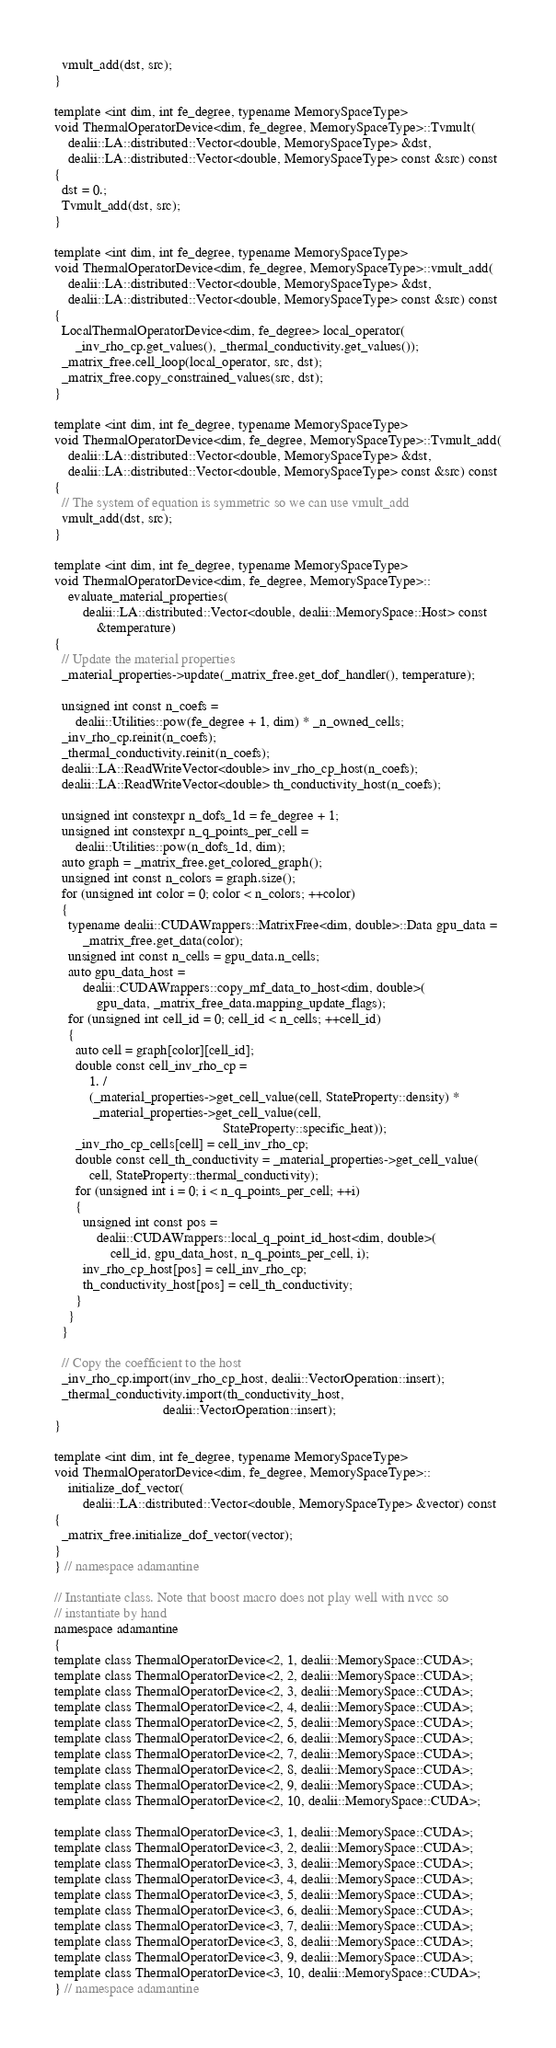Convert code to text. <code><loc_0><loc_0><loc_500><loc_500><_Cuda_>  vmult_add(dst, src);
}

template <int dim, int fe_degree, typename MemorySpaceType>
void ThermalOperatorDevice<dim, fe_degree, MemorySpaceType>::Tvmult(
    dealii::LA::distributed::Vector<double, MemorySpaceType> &dst,
    dealii::LA::distributed::Vector<double, MemorySpaceType> const &src) const
{
  dst = 0.;
  Tvmult_add(dst, src);
}

template <int dim, int fe_degree, typename MemorySpaceType>
void ThermalOperatorDevice<dim, fe_degree, MemorySpaceType>::vmult_add(
    dealii::LA::distributed::Vector<double, MemorySpaceType> &dst,
    dealii::LA::distributed::Vector<double, MemorySpaceType> const &src) const
{
  LocalThermalOperatorDevice<dim, fe_degree> local_operator(
      _inv_rho_cp.get_values(), _thermal_conductivity.get_values());
  _matrix_free.cell_loop(local_operator, src, dst);
  _matrix_free.copy_constrained_values(src, dst);
}

template <int dim, int fe_degree, typename MemorySpaceType>
void ThermalOperatorDevice<dim, fe_degree, MemorySpaceType>::Tvmult_add(
    dealii::LA::distributed::Vector<double, MemorySpaceType> &dst,
    dealii::LA::distributed::Vector<double, MemorySpaceType> const &src) const
{
  // The system of equation is symmetric so we can use vmult_add
  vmult_add(dst, src);
}

template <int dim, int fe_degree, typename MemorySpaceType>
void ThermalOperatorDevice<dim, fe_degree, MemorySpaceType>::
    evaluate_material_properties(
        dealii::LA::distributed::Vector<double, dealii::MemorySpace::Host> const
            &temperature)
{
  // Update the material properties
  _material_properties->update(_matrix_free.get_dof_handler(), temperature);

  unsigned int const n_coefs =
      dealii::Utilities::pow(fe_degree + 1, dim) * _n_owned_cells;
  _inv_rho_cp.reinit(n_coefs);
  _thermal_conductivity.reinit(n_coefs);
  dealii::LA::ReadWriteVector<double> inv_rho_cp_host(n_coefs);
  dealii::LA::ReadWriteVector<double> th_conductivity_host(n_coefs);

  unsigned int constexpr n_dofs_1d = fe_degree + 1;
  unsigned int constexpr n_q_points_per_cell =
      dealii::Utilities::pow(n_dofs_1d, dim);
  auto graph = _matrix_free.get_colored_graph();
  unsigned int const n_colors = graph.size();
  for (unsigned int color = 0; color < n_colors; ++color)
  {
    typename dealii::CUDAWrappers::MatrixFree<dim, double>::Data gpu_data =
        _matrix_free.get_data(color);
    unsigned int const n_cells = gpu_data.n_cells;
    auto gpu_data_host =
        dealii::CUDAWrappers::copy_mf_data_to_host<dim, double>(
            gpu_data, _matrix_free_data.mapping_update_flags);
    for (unsigned int cell_id = 0; cell_id < n_cells; ++cell_id)
    {
      auto cell = graph[color][cell_id];
      double const cell_inv_rho_cp =
          1. /
          (_material_properties->get_cell_value(cell, StateProperty::density) *
           _material_properties->get_cell_value(cell,
                                                StateProperty::specific_heat));
      _inv_rho_cp_cells[cell] = cell_inv_rho_cp;
      double const cell_th_conductivity = _material_properties->get_cell_value(
          cell, StateProperty::thermal_conductivity);
      for (unsigned int i = 0; i < n_q_points_per_cell; ++i)
      {
        unsigned int const pos =
            dealii::CUDAWrappers::local_q_point_id_host<dim, double>(
                cell_id, gpu_data_host, n_q_points_per_cell, i);
        inv_rho_cp_host[pos] = cell_inv_rho_cp;
        th_conductivity_host[pos] = cell_th_conductivity;
      }
    }
  }

  // Copy the coefficient to the host
  _inv_rho_cp.import(inv_rho_cp_host, dealii::VectorOperation::insert);
  _thermal_conductivity.import(th_conductivity_host,
                               dealii::VectorOperation::insert);
}

template <int dim, int fe_degree, typename MemorySpaceType>
void ThermalOperatorDevice<dim, fe_degree, MemorySpaceType>::
    initialize_dof_vector(
        dealii::LA::distributed::Vector<double, MemorySpaceType> &vector) const
{
  _matrix_free.initialize_dof_vector(vector);
}
} // namespace adamantine

// Instantiate class. Note that boost macro does not play well with nvcc so
// instantiate by hand
namespace adamantine
{
template class ThermalOperatorDevice<2, 1, dealii::MemorySpace::CUDA>;
template class ThermalOperatorDevice<2, 2, dealii::MemorySpace::CUDA>;
template class ThermalOperatorDevice<2, 3, dealii::MemorySpace::CUDA>;
template class ThermalOperatorDevice<2, 4, dealii::MemorySpace::CUDA>;
template class ThermalOperatorDevice<2, 5, dealii::MemorySpace::CUDA>;
template class ThermalOperatorDevice<2, 6, dealii::MemorySpace::CUDA>;
template class ThermalOperatorDevice<2, 7, dealii::MemorySpace::CUDA>;
template class ThermalOperatorDevice<2, 8, dealii::MemorySpace::CUDA>;
template class ThermalOperatorDevice<2, 9, dealii::MemorySpace::CUDA>;
template class ThermalOperatorDevice<2, 10, dealii::MemorySpace::CUDA>;

template class ThermalOperatorDevice<3, 1, dealii::MemorySpace::CUDA>;
template class ThermalOperatorDevice<3, 2, dealii::MemorySpace::CUDA>;
template class ThermalOperatorDevice<3, 3, dealii::MemorySpace::CUDA>;
template class ThermalOperatorDevice<3, 4, dealii::MemorySpace::CUDA>;
template class ThermalOperatorDevice<3, 5, dealii::MemorySpace::CUDA>;
template class ThermalOperatorDevice<3, 6, dealii::MemorySpace::CUDA>;
template class ThermalOperatorDevice<3, 7, dealii::MemorySpace::CUDA>;
template class ThermalOperatorDevice<3, 8, dealii::MemorySpace::CUDA>;
template class ThermalOperatorDevice<3, 9, dealii::MemorySpace::CUDA>;
template class ThermalOperatorDevice<3, 10, dealii::MemorySpace::CUDA>;
} // namespace adamantine
</code> 